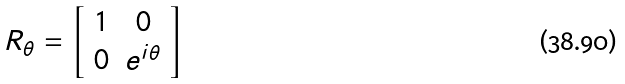Convert formula to latex. <formula><loc_0><loc_0><loc_500><loc_500>R _ { \theta } = \left [ \begin{array} { c c } 1 & 0 \\ 0 & e ^ { { i } \theta } \end{array} \right ]</formula> 